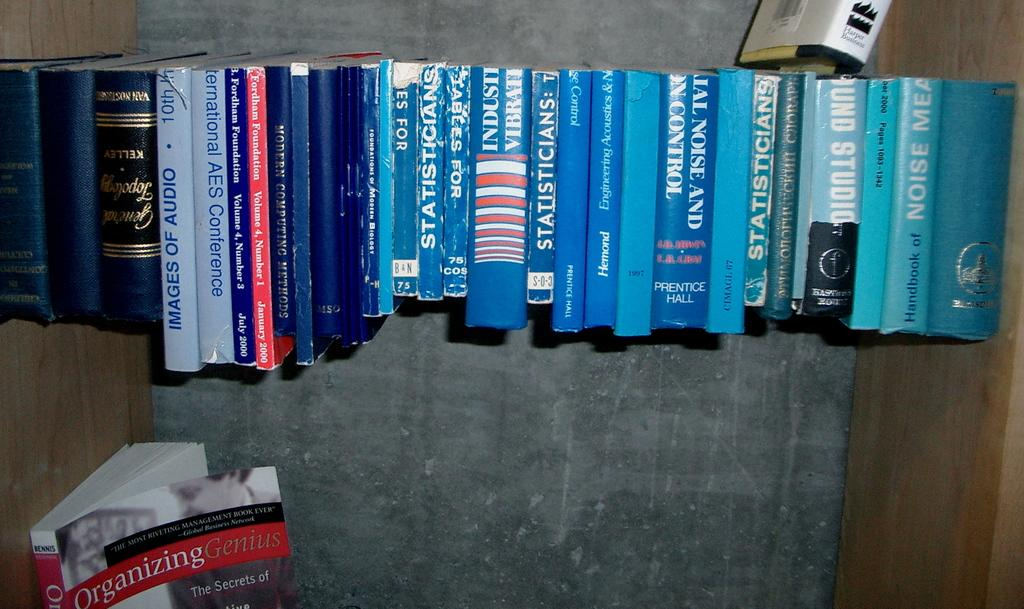<image>
Present a compact description of the photo's key features. Book spines in various shades of blue are lined up with an outlier with a red spine called Organizing Genius. 